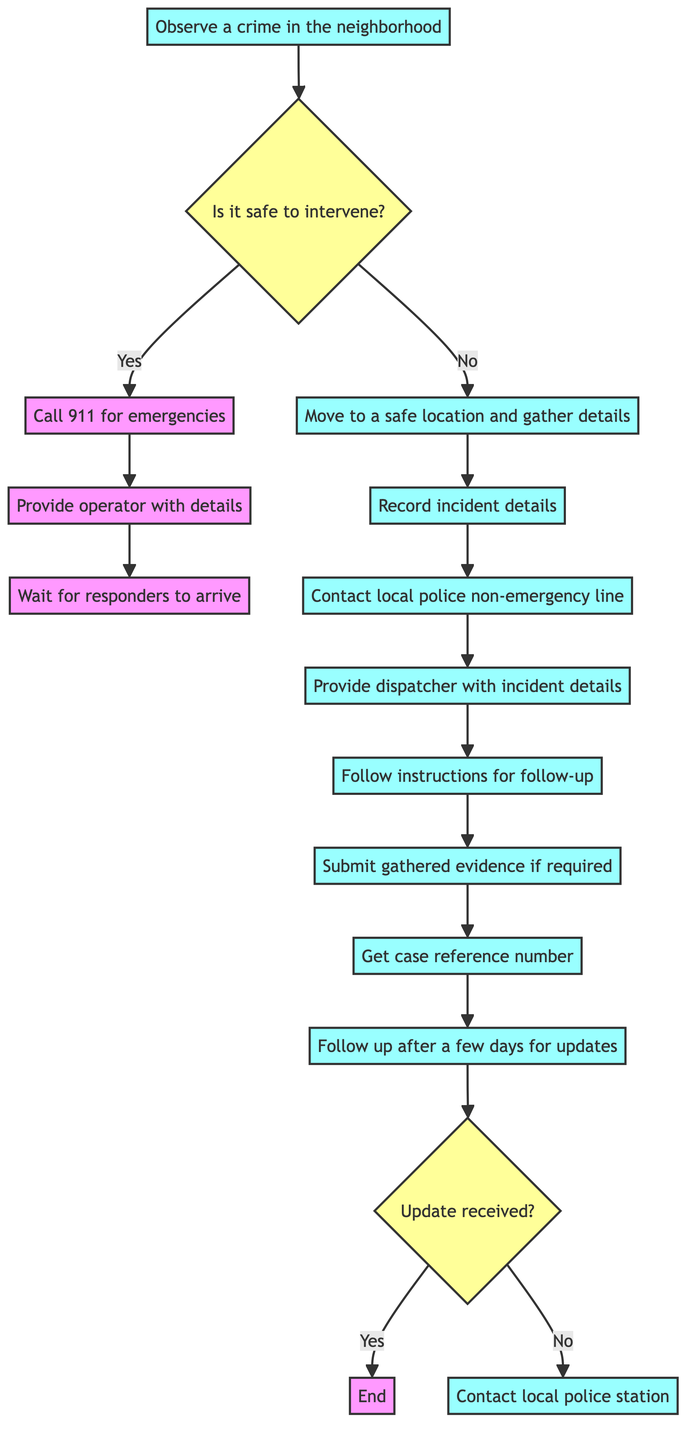What is the first action to take when observing a crime? The first action specified in the flowchart is to "Observe a crime in the neighborhood." This is the starting point of the instruction process.
Answer: Observe a crime in the neighborhood How many decision points are in the diagram? The diagram contains two decision points, represented by the nodes asking if it's safe to intervene and whether an update was received. These are central junctions that determine the flow of actions.
Answer: 2 What happens if you decide it is safe to intervene? If it is safe to intervene, the flowchart directs you to "Call 911 for emergencies." This indicates an immediate action to report the crime to emergency services.
Answer: Call 911 for emergencies What is the action after contacting the local police non-emergency line? After contacting the local police non-emergency line, you "Provide the dispatcher with incident details." This step is key to ensuring that the police have the necessary information about the crime.
Answer: Provide the dispatcher with incident details What should be done if no update is received after a few days? If no update is received after a few days, the instruction is to "Contact local police station." This ensures that you can follow up and seek further information regarding the case.
Answer: Contact local police station If you choose not to intervene, what is the next step? If you choose not to intervene, the next step is to "Move to a safe location and gather details." This emphasizes the importance of safety while still gathering essential information about the incident.
Answer: Move to a safe location and gather details What is the final step if an update is received? If an update is received, the final step is to "End." This indicates that the process concludes effectively if the information has been communicated successfully and followed up on.
Answer: End What is required if you submit any gathered evidence? If you submit any gathered evidence, you must "Get a case reference number for future follow-up." This is critical for tracking the case and ensuring your evidence is linked to the right incident.
Answer: Get a case reference number for future follow-up 